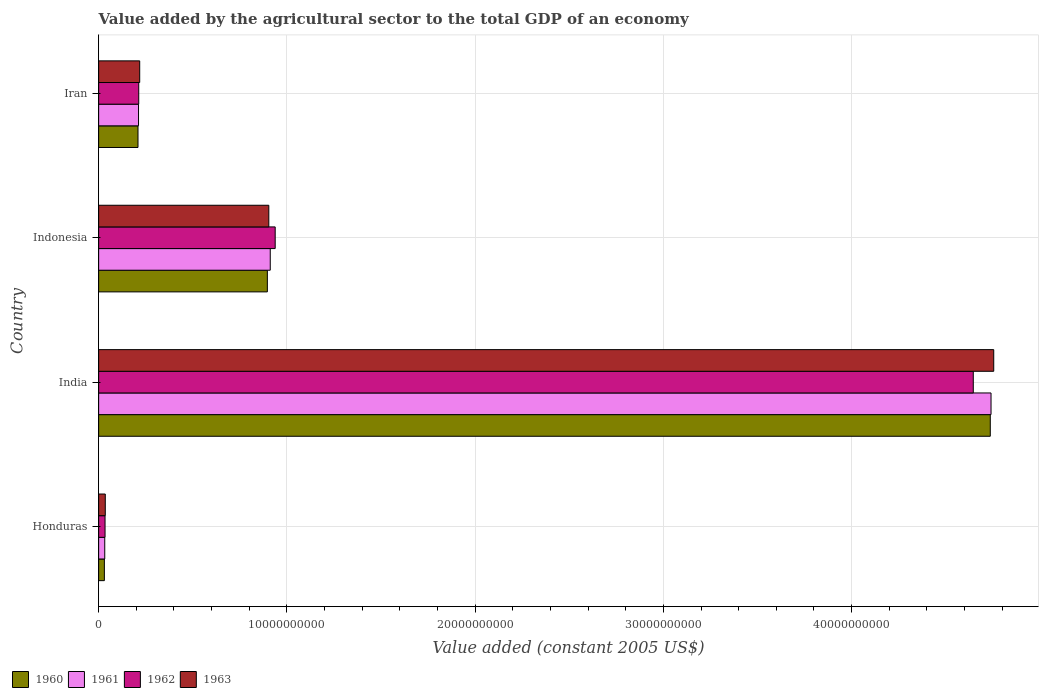How many groups of bars are there?
Give a very brief answer. 4. Are the number of bars per tick equal to the number of legend labels?
Your answer should be compact. Yes. In how many cases, is the number of bars for a given country not equal to the number of legend labels?
Provide a succinct answer. 0. What is the value added by the agricultural sector in 1962 in Indonesia?
Keep it short and to the point. 9.38e+09. Across all countries, what is the maximum value added by the agricultural sector in 1961?
Give a very brief answer. 4.74e+1. Across all countries, what is the minimum value added by the agricultural sector in 1963?
Your answer should be very brief. 3.53e+08. In which country was the value added by the agricultural sector in 1962 maximum?
Provide a succinct answer. India. In which country was the value added by the agricultural sector in 1960 minimum?
Offer a very short reply. Honduras. What is the total value added by the agricultural sector in 1962 in the graph?
Offer a very short reply. 5.83e+1. What is the difference between the value added by the agricultural sector in 1963 in Honduras and that in Iran?
Your response must be concise. -1.83e+09. What is the difference between the value added by the agricultural sector in 1961 in Honduras and the value added by the agricultural sector in 1962 in Indonesia?
Offer a terse response. -9.05e+09. What is the average value added by the agricultural sector in 1961 per country?
Offer a terse response. 1.47e+1. What is the difference between the value added by the agricultural sector in 1962 and value added by the agricultural sector in 1960 in Honduras?
Ensure brevity in your answer.  3.54e+07. What is the ratio of the value added by the agricultural sector in 1961 in Honduras to that in India?
Your response must be concise. 0.01. Is the value added by the agricultural sector in 1963 in Honduras less than that in Iran?
Make the answer very short. Yes. Is the difference between the value added by the agricultural sector in 1962 in India and Indonesia greater than the difference between the value added by the agricultural sector in 1960 in India and Indonesia?
Your answer should be very brief. No. What is the difference between the highest and the second highest value added by the agricultural sector in 1960?
Provide a short and direct response. 3.84e+1. What is the difference between the highest and the lowest value added by the agricultural sector in 1960?
Provide a short and direct response. 4.71e+1. Is the sum of the value added by the agricultural sector in 1963 in India and Iran greater than the maximum value added by the agricultural sector in 1962 across all countries?
Make the answer very short. Yes. What does the 4th bar from the bottom in Indonesia represents?
Make the answer very short. 1963. Is it the case that in every country, the sum of the value added by the agricultural sector in 1962 and value added by the agricultural sector in 1961 is greater than the value added by the agricultural sector in 1960?
Offer a very short reply. Yes. Are all the bars in the graph horizontal?
Provide a short and direct response. Yes. How many countries are there in the graph?
Keep it short and to the point. 4. Are the values on the major ticks of X-axis written in scientific E-notation?
Keep it short and to the point. No. Does the graph contain any zero values?
Ensure brevity in your answer.  No. How many legend labels are there?
Make the answer very short. 4. How are the legend labels stacked?
Keep it short and to the point. Horizontal. What is the title of the graph?
Your response must be concise. Value added by the agricultural sector to the total GDP of an economy. Does "1984" appear as one of the legend labels in the graph?
Keep it short and to the point. No. What is the label or title of the X-axis?
Offer a very short reply. Value added (constant 2005 US$). What is the label or title of the Y-axis?
Keep it short and to the point. Country. What is the Value added (constant 2005 US$) of 1960 in Honduras?
Offer a very short reply. 3.05e+08. What is the Value added (constant 2005 US$) in 1961 in Honduras?
Your response must be concise. 3.25e+08. What is the Value added (constant 2005 US$) in 1962 in Honduras?
Offer a terse response. 3.41e+08. What is the Value added (constant 2005 US$) of 1963 in Honduras?
Offer a very short reply. 3.53e+08. What is the Value added (constant 2005 US$) of 1960 in India?
Make the answer very short. 4.74e+1. What is the Value added (constant 2005 US$) of 1961 in India?
Make the answer very short. 4.74e+1. What is the Value added (constant 2005 US$) in 1962 in India?
Offer a terse response. 4.65e+1. What is the Value added (constant 2005 US$) in 1963 in India?
Your response must be concise. 4.76e+1. What is the Value added (constant 2005 US$) in 1960 in Indonesia?
Your answer should be compact. 8.96e+09. What is the Value added (constant 2005 US$) of 1961 in Indonesia?
Provide a short and direct response. 9.12e+09. What is the Value added (constant 2005 US$) in 1962 in Indonesia?
Ensure brevity in your answer.  9.38e+09. What is the Value added (constant 2005 US$) in 1963 in Indonesia?
Your answer should be very brief. 9.04e+09. What is the Value added (constant 2005 US$) of 1960 in Iran?
Your answer should be very brief. 2.09e+09. What is the Value added (constant 2005 US$) in 1961 in Iran?
Ensure brevity in your answer.  2.12e+09. What is the Value added (constant 2005 US$) in 1962 in Iran?
Keep it short and to the point. 2.13e+09. What is the Value added (constant 2005 US$) in 1963 in Iran?
Your answer should be very brief. 2.18e+09. Across all countries, what is the maximum Value added (constant 2005 US$) in 1960?
Make the answer very short. 4.74e+1. Across all countries, what is the maximum Value added (constant 2005 US$) of 1961?
Your response must be concise. 4.74e+1. Across all countries, what is the maximum Value added (constant 2005 US$) in 1962?
Offer a terse response. 4.65e+1. Across all countries, what is the maximum Value added (constant 2005 US$) of 1963?
Keep it short and to the point. 4.76e+1. Across all countries, what is the minimum Value added (constant 2005 US$) in 1960?
Make the answer very short. 3.05e+08. Across all countries, what is the minimum Value added (constant 2005 US$) of 1961?
Provide a succinct answer. 3.25e+08. Across all countries, what is the minimum Value added (constant 2005 US$) in 1962?
Give a very brief answer. 3.41e+08. Across all countries, what is the minimum Value added (constant 2005 US$) of 1963?
Your response must be concise. 3.53e+08. What is the total Value added (constant 2005 US$) in 1960 in the graph?
Your answer should be compact. 5.87e+1. What is the total Value added (constant 2005 US$) of 1961 in the graph?
Provide a short and direct response. 5.90e+1. What is the total Value added (constant 2005 US$) in 1962 in the graph?
Ensure brevity in your answer.  5.83e+1. What is the total Value added (constant 2005 US$) in 1963 in the graph?
Provide a succinct answer. 5.91e+1. What is the difference between the Value added (constant 2005 US$) in 1960 in Honduras and that in India?
Give a very brief answer. -4.71e+1. What is the difference between the Value added (constant 2005 US$) of 1961 in Honduras and that in India?
Make the answer very short. -4.71e+1. What is the difference between the Value added (constant 2005 US$) in 1962 in Honduras and that in India?
Ensure brevity in your answer.  -4.61e+1. What is the difference between the Value added (constant 2005 US$) in 1963 in Honduras and that in India?
Provide a short and direct response. -4.72e+1. What is the difference between the Value added (constant 2005 US$) of 1960 in Honduras and that in Indonesia?
Provide a succinct answer. -8.66e+09. What is the difference between the Value added (constant 2005 US$) in 1961 in Honduras and that in Indonesia?
Provide a short and direct response. -8.79e+09. What is the difference between the Value added (constant 2005 US$) in 1962 in Honduras and that in Indonesia?
Offer a terse response. -9.04e+09. What is the difference between the Value added (constant 2005 US$) in 1963 in Honduras and that in Indonesia?
Make the answer very short. -8.69e+09. What is the difference between the Value added (constant 2005 US$) in 1960 in Honduras and that in Iran?
Keep it short and to the point. -1.79e+09. What is the difference between the Value added (constant 2005 US$) in 1961 in Honduras and that in Iran?
Keep it short and to the point. -1.79e+09. What is the difference between the Value added (constant 2005 US$) in 1962 in Honduras and that in Iran?
Give a very brief answer. -1.79e+09. What is the difference between the Value added (constant 2005 US$) of 1963 in Honduras and that in Iran?
Make the answer very short. -1.83e+09. What is the difference between the Value added (constant 2005 US$) in 1960 in India and that in Indonesia?
Provide a succinct answer. 3.84e+1. What is the difference between the Value added (constant 2005 US$) of 1961 in India and that in Indonesia?
Make the answer very short. 3.83e+1. What is the difference between the Value added (constant 2005 US$) of 1962 in India and that in Indonesia?
Ensure brevity in your answer.  3.71e+1. What is the difference between the Value added (constant 2005 US$) in 1963 in India and that in Indonesia?
Your response must be concise. 3.85e+1. What is the difference between the Value added (constant 2005 US$) in 1960 in India and that in Iran?
Offer a very short reply. 4.53e+1. What is the difference between the Value added (constant 2005 US$) of 1961 in India and that in Iran?
Provide a succinct answer. 4.53e+1. What is the difference between the Value added (constant 2005 US$) of 1962 in India and that in Iran?
Offer a terse response. 4.43e+1. What is the difference between the Value added (constant 2005 US$) of 1963 in India and that in Iran?
Your answer should be very brief. 4.54e+1. What is the difference between the Value added (constant 2005 US$) of 1960 in Indonesia and that in Iran?
Your answer should be compact. 6.87e+09. What is the difference between the Value added (constant 2005 US$) in 1961 in Indonesia and that in Iran?
Provide a short and direct response. 7.00e+09. What is the difference between the Value added (constant 2005 US$) in 1962 in Indonesia and that in Iran?
Your answer should be compact. 7.25e+09. What is the difference between the Value added (constant 2005 US$) in 1963 in Indonesia and that in Iran?
Keep it short and to the point. 6.86e+09. What is the difference between the Value added (constant 2005 US$) of 1960 in Honduras and the Value added (constant 2005 US$) of 1961 in India?
Provide a short and direct response. -4.71e+1. What is the difference between the Value added (constant 2005 US$) in 1960 in Honduras and the Value added (constant 2005 US$) in 1962 in India?
Give a very brief answer. -4.62e+1. What is the difference between the Value added (constant 2005 US$) of 1960 in Honduras and the Value added (constant 2005 US$) of 1963 in India?
Your answer should be very brief. -4.72e+1. What is the difference between the Value added (constant 2005 US$) of 1961 in Honduras and the Value added (constant 2005 US$) of 1962 in India?
Ensure brevity in your answer.  -4.61e+1. What is the difference between the Value added (constant 2005 US$) of 1961 in Honduras and the Value added (constant 2005 US$) of 1963 in India?
Your answer should be very brief. -4.72e+1. What is the difference between the Value added (constant 2005 US$) in 1962 in Honduras and the Value added (constant 2005 US$) in 1963 in India?
Your answer should be compact. -4.72e+1. What is the difference between the Value added (constant 2005 US$) of 1960 in Honduras and the Value added (constant 2005 US$) of 1961 in Indonesia?
Offer a very short reply. -8.81e+09. What is the difference between the Value added (constant 2005 US$) of 1960 in Honduras and the Value added (constant 2005 US$) of 1962 in Indonesia?
Your answer should be compact. -9.07e+09. What is the difference between the Value added (constant 2005 US$) of 1960 in Honduras and the Value added (constant 2005 US$) of 1963 in Indonesia?
Offer a terse response. -8.73e+09. What is the difference between the Value added (constant 2005 US$) of 1961 in Honduras and the Value added (constant 2005 US$) of 1962 in Indonesia?
Your answer should be compact. -9.05e+09. What is the difference between the Value added (constant 2005 US$) in 1961 in Honduras and the Value added (constant 2005 US$) in 1963 in Indonesia?
Offer a terse response. -8.72e+09. What is the difference between the Value added (constant 2005 US$) in 1962 in Honduras and the Value added (constant 2005 US$) in 1963 in Indonesia?
Your answer should be very brief. -8.70e+09. What is the difference between the Value added (constant 2005 US$) of 1960 in Honduras and the Value added (constant 2005 US$) of 1961 in Iran?
Provide a short and direct response. -1.81e+09. What is the difference between the Value added (constant 2005 US$) of 1960 in Honduras and the Value added (constant 2005 US$) of 1962 in Iran?
Offer a very short reply. -1.82e+09. What is the difference between the Value added (constant 2005 US$) in 1960 in Honduras and the Value added (constant 2005 US$) in 1963 in Iran?
Ensure brevity in your answer.  -1.88e+09. What is the difference between the Value added (constant 2005 US$) of 1961 in Honduras and the Value added (constant 2005 US$) of 1962 in Iran?
Ensure brevity in your answer.  -1.80e+09. What is the difference between the Value added (constant 2005 US$) of 1961 in Honduras and the Value added (constant 2005 US$) of 1963 in Iran?
Your answer should be compact. -1.86e+09. What is the difference between the Value added (constant 2005 US$) of 1962 in Honduras and the Value added (constant 2005 US$) of 1963 in Iran?
Ensure brevity in your answer.  -1.84e+09. What is the difference between the Value added (constant 2005 US$) in 1960 in India and the Value added (constant 2005 US$) in 1961 in Indonesia?
Give a very brief answer. 3.83e+1. What is the difference between the Value added (constant 2005 US$) in 1960 in India and the Value added (constant 2005 US$) in 1962 in Indonesia?
Make the answer very short. 3.80e+1. What is the difference between the Value added (constant 2005 US$) of 1960 in India and the Value added (constant 2005 US$) of 1963 in Indonesia?
Provide a succinct answer. 3.83e+1. What is the difference between the Value added (constant 2005 US$) of 1961 in India and the Value added (constant 2005 US$) of 1962 in Indonesia?
Provide a short and direct response. 3.80e+1. What is the difference between the Value added (constant 2005 US$) in 1961 in India and the Value added (constant 2005 US$) in 1963 in Indonesia?
Ensure brevity in your answer.  3.84e+1. What is the difference between the Value added (constant 2005 US$) of 1962 in India and the Value added (constant 2005 US$) of 1963 in Indonesia?
Ensure brevity in your answer.  3.74e+1. What is the difference between the Value added (constant 2005 US$) of 1960 in India and the Value added (constant 2005 US$) of 1961 in Iran?
Offer a very short reply. 4.52e+1. What is the difference between the Value added (constant 2005 US$) in 1960 in India and the Value added (constant 2005 US$) in 1962 in Iran?
Keep it short and to the point. 4.52e+1. What is the difference between the Value added (constant 2005 US$) in 1960 in India and the Value added (constant 2005 US$) in 1963 in Iran?
Your response must be concise. 4.52e+1. What is the difference between the Value added (constant 2005 US$) in 1961 in India and the Value added (constant 2005 US$) in 1962 in Iran?
Make the answer very short. 4.53e+1. What is the difference between the Value added (constant 2005 US$) of 1961 in India and the Value added (constant 2005 US$) of 1963 in Iran?
Offer a very short reply. 4.52e+1. What is the difference between the Value added (constant 2005 US$) in 1962 in India and the Value added (constant 2005 US$) in 1963 in Iran?
Your response must be concise. 4.43e+1. What is the difference between the Value added (constant 2005 US$) of 1960 in Indonesia and the Value added (constant 2005 US$) of 1961 in Iran?
Your answer should be very brief. 6.84e+09. What is the difference between the Value added (constant 2005 US$) of 1960 in Indonesia and the Value added (constant 2005 US$) of 1962 in Iran?
Provide a short and direct response. 6.83e+09. What is the difference between the Value added (constant 2005 US$) in 1960 in Indonesia and the Value added (constant 2005 US$) in 1963 in Iran?
Give a very brief answer. 6.78e+09. What is the difference between the Value added (constant 2005 US$) in 1961 in Indonesia and the Value added (constant 2005 US$) in 1962 in Iran?
Your response must be concise. 6.99e+09. What is the difference between the Value added (constant 2005 US$) in 1961 in Indonesia and the Value added (constant 2005 US$) in 1963 in Iran?
Provide a succinct answer. 6.94e+09. What is the difference between the Value added (constant 2005 US$) in 1962 in Indonesia and the Value added (constant 2005 US$) in 1963 in Iran?
Provide a succinct answer. 7.20e+09. What is the average Value added (constant 2005 US$) in 1960 per country?
Offer a very short reply. 1.47e+1. What is the average Value added (constant 2005 US$) of 1961 per country?
Offer a very short reply. 1.47e+1. What is the average Value added (constant 2005 US$) of 1962 per country?
Give a very brief answer. 1.46e+1. What is the average Value added (constant 2005 US$) in 1963 per country?
Your answer should be compact. 1.48e+1. What is the difference between the Value added (constant 2005 US$) in 1960 and Value added (constant 2005 US$) in 1961 in Honduras?
Keep it short and to the point. -1.99e+07. What is the difference between the Value added (constant 2005 US$) of 1960 and Value added (constant 2005 US$) of 1962 in Honduras?
Offer a very short reply. -3.54e+07. What is the difference between the Value added (constant 2005 US$) in 1960 and Value added (constant 2005 US$) in 1963 in Honduras?
Your answer should be very brief. -4.78e+07. What is the difference between the Value added (constant 2005 US$) in 1961 and Value added (constant 2005 US$) in 1962 in Honduras?
Ensure brevity in your answer.  -1.55e+07. What is the difference between the Value added (constant 2005 US$) of 1961 and Value added (constant 2005 US$) of 1963 in Honduras?
Ensure brevity in your answer.  -2.79e+07. What is the difference between the Value added (constant 2005 US$) in 1962 and Value added (constant 2005 US$) in 1963 in Honduras?
Offer a terse response. -1.24e+07. What is the difference between the Value added (constant 2005 US$) of 1960 and Value added (constant 2005 US$) of 1961 in India?
Make the answer very short. -3.99e+07. What is the difference between the Value added (constant 2005 US$) of 1960 and Value added (constant 2005 US$) of 1962 in India?
Give a very brief answer. 9.03e+08. What is the difference between the Value added (constant 2005 US$) of 1960 and Value added (constant 2005 US$) of 1963 in India?
Your response must be concise. -1.84e+08. What is the difference between the Value added (constant 2005 US$) in 1961 and Value added (constant 2005 US$) in 1962 in India?
Provide a succinct answer. 9.43e+08. What is the difference between the Value added (constant 2005 US$) of 1961 and Value added (constant 2005 US$) of 1963 in India?
Keep it short and to the point. -1.44e+08. What is the difference between the Value added (constant 2005 US$) of 1962 and Value added (constant 2005 US$) of 1963 in India?
Provide a succinct answer. -1.09e+09. What is the difference between the Value added (constant 2005 US$) in 1960 and Value added (constant 2005 US$) in 1961 in Indonesia?
Provide a short and direct response. -1.54e+08. What is the difference between the Value added (constant 2005 US$) in 1960 and Value added (constant 2005 US$) in 1962 in Indonesia?
Your response must be concise. -4.16e+08. What is the difference between the Value added (constant 2005 US$) of 1960 and Value added (constant 2005 US$) of 1963 in Indonesia?
Give a very brief answer. -7.71e+07. What is the difference between the Value added (constant 2005 US$) in 1961 and Value added (constant 2005 US$) in 1962 in Indonesia?
Your answer should be very brief. -2.62e+08. What is the difference between the Value added (constant 2005 US$) of 1961 and Value added (constant 2005 US$) of 1963 in Indonesia?
Provide a short and direct response. 7.71e+07. What is the difference between the Value added (constant 2005 US$) of 1962 and Value added (constant 2005 US$) of 1963 in Indonesia?
Keep it short and to the point. 3.39e+08. What is the difference between the Value added (constant 2005 US$) in 1960 and Value added (constant 2005 US$) in 1961 in Iran?
Make the answer very short. -2.84e+07. What is the difference between the Value added (constant 2005 US$) in 1960 and Value added (constant 2005 US$) in 1962 in Iran?
Keep it short and to the point. -3.89e+07. What is the difference between the Value added (constant 2005 US$) of 1960 and Value added (constant 2005 US$) of 1963 in Iran?
Give a very brief answer. -9.02e+07. What is the difference between the Value added (constant 2005 US$) in 1961 and Value added (constant 2005 US$) in 1962 in Iran?
Make the answer very short. -1.05e+07. What is the difference between the Value added (constant 2005 US$) in 1961 and Value added (constant 2005 US$) in 1963 in Iran?
Your answer should be very brief. -6.18e+07. What is the difference between the Value added (constant 2005 US$) in 1962 and Value added (constant 2005 US$) in 1963 in Iran?
Provide a short and direct response. -5.13e+07. What is the ratio of the Value added (constant 2005 US$) in 1960 in Honduras to that in India?
Your answer should be compact. 0.01. What is the ratio of the Value added (constant 2005 US$) of 1961 in Honduras to that in India?
Keep it short and to the point. 0.01. What is the ratio of the Value added (constant 2005 US$) of 1962 in Honduras to that in India?
Offer a terse response. 0.01. What is the ratio of the Value added (constant 2005 US$) of 1963 in Honduras to that in India?
Your answer should be compact. 0.01. What is the ratio of the Value added (constant 2005 US$) of 1960 in Honduras to that in Indonesia?
Your response must be concise. 0.03. What is the ratio of the Value added (constant 2005 US$) of 1961 in Honduras to that in Indonesia?
Offer a terse response. 0.04. What is the ratio of the Value added (constant 2005 US$) in 1962 in Honduras to that in Indonesia?
Give a very brief answer. 0.04. What is the ratio of the Value added (constant 2005 US$) in 1963 in Honduras to that in Indonesia?
Offer a very short reply. 0.04. What is the ratio of the Value added (constant 2005 US$) in 1960 in Honduras to that in Iran?
Offer a terse response. 0.15. What is the ratio of the Value added (constant 2005 US$) of 1961 in Honduras to that in Iran?
Your response must be concise. 0.15. What is the ratio of the Value added (constant 2005 US$) in 1962 in Honduras to that in Iran?
Make the answer very short. 0.16. What is the ratio of the Value added (constant 2005 US$) in 1963 in Honduras to that in Iran?
Your answer should be very brief. 0.16. What is the ratio of the Value added (constant 2005 US$) of 1960 in India to that in Indonesia?
Keep it short and to the point. 5.28. What is the ratio of the Value added (constant 2005 US$) of 1961 in India to that in Indonesia?
Give a very brief answer. 5.2. What is the ratio of the Value added (constant 2005 US$) in 1962 in India to that in Indonesia?
Give a very brief answer. 4.95. What is the ratio of the Value added (constant 2005 US$) of 1963 in India to that in Indonesia?
Ensure brevity in your answer.  5.26. What is the ratio of the Value added (constant 2005 US$) in 1960 in India to that in Iran?
Your answer should be very brief. 22.65. What is the ratio of the Value added (constant 2005 US$) of 1961 in India to that in Iran?
Provide a short and direct response. 22.37. What is the ratio of the Value added (constant 2005 US$) in 1962 in India to that in Iran?
Your answer should be very brief. 21.81. What is the ratio of the Value added (constant 2005 US$) of 1963 in India to that in Iran?
Offer a very short reply. 21.8. What is the ratio of the Value added (constant 2005 US$) in 1960 in Indonesia to that in Iran?
Give a very brief answer. 4.29. What is the ratio of the Value added (constant 2005 US$) of 1961 in Indonesia to that in Iran?
Make the answer very short. 4.3. What is the ratio of the Value added (constant 2005 US$) in 1962 in Indonesia to that in Iran?
Ensure brevity in your answer.  4.4. What is the ratio of the Value added (constant 2005 US$) in 1963 in Indonesia to that in Iran?
Provide a succinct answer. 4.14. What is the difference between the highest and the second highest Value added (constant 2005 US$) in 1960?
Provide a succinct answer. 3.84e+1. What is the difference between the highest and the second highest Value added (constant 2005 US$) in 1961?
Your answer should be compact. 3.83e+1. What is the difference between the highest and the second highest Value added (constant 2005 US$) in 1962?
Offer a terse response. 3.71e+1. What is the difference between the highest and the second highest Value added (constant 2005 US$) in 1963?
Your answer should be compact. 3.85e+1. What is the difference between the highest and the lowest Value added (constant 2005 US$) of 1960?
Offer a terse response. 4.71e+1. What is the difference between the highest and the lowest Value added (constant 2005 US$) in 1961?
Your response must be concise. 4.71e+1. What is the difference between the highest and the lowest Value added (constant 2005 US$) in 1962?
Your response must be concise. 4.61e+1. What is the difference between the highest and the lowest Value added (constant 2005 US$) of 1963?
Your response must be concise. 4.72e+1. 